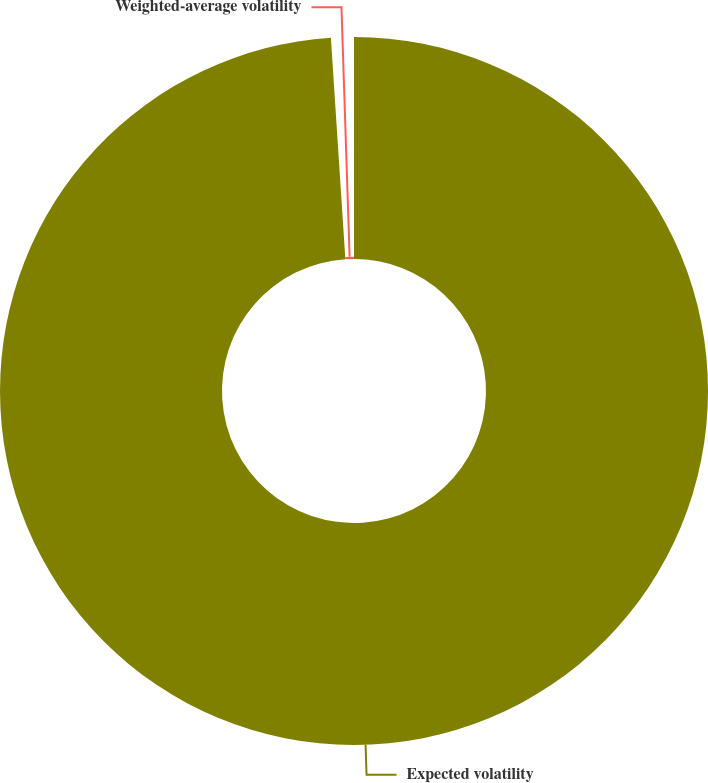Convert chart. <chart><loc_0><loc_0><loc_500><loc_500><pie_chart><fcel>Expected volatility<fcel>Weighted-average volatility<nl><fcel>98.96%<fcel>1.04%<nl></chart> 